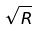Convert formula to latex. <formula><loc_0><loc_0><loc_500><loc_500>\sqrt { R }</formula> 